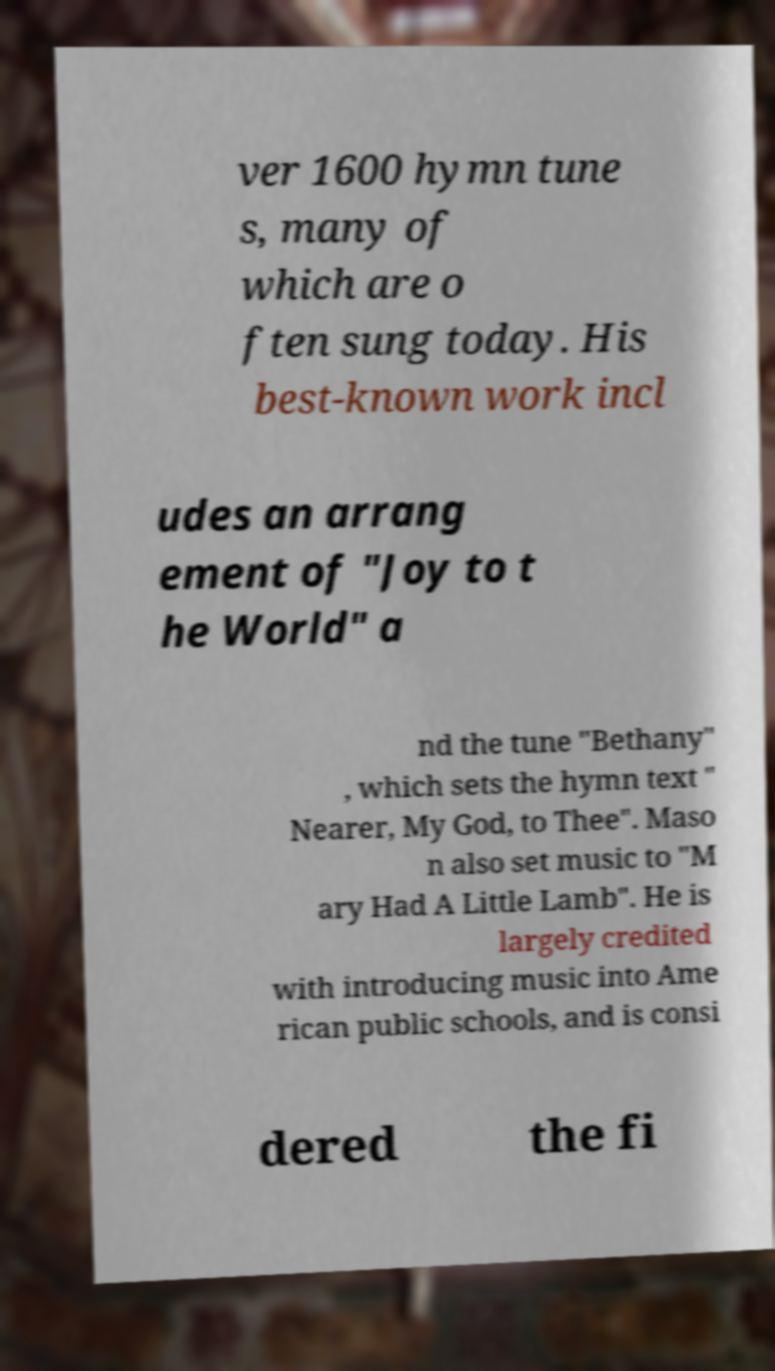For documentation purposes, I need the text within this image transcribed. Could you provide that? ver 1600 hymn tune s, many of which are o ften sung today. His best-known work incl udes an arrang ement of "Joy to t he World" a nd the tune "Bethany" , which sets the hymn text " Nearer, My God, to Thee". Maso n also set music to "M ary Had A Little Lamb". He is largely credited with introducing music into Ame rican public schools, and is consi dered the fi 